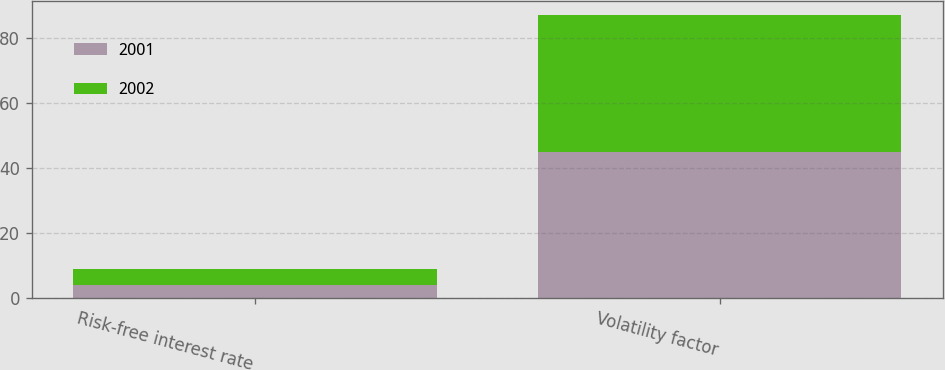<chart> <loc_0><loc_0><loc_500><loc_500><stacked_bar_chart><ecel><fcel>Risk-free interest rate<fcel>Volatility factor<nl><fcel>2001<fcel>4.16<fcel>45<nl><fcel>2002<fcel>4.96<fcel>42<nl></chart> 